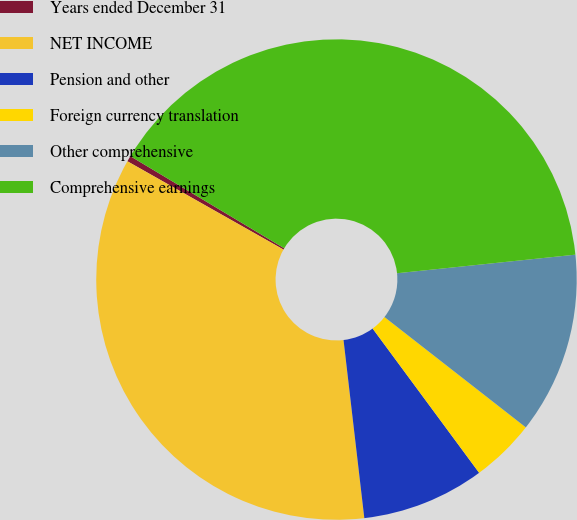Convert chart to OTSL. <chart><loc_0><loc_0><loc_500><loc_500><pie_chart><fcel>Years ended December 31<fcel>NET INCOME<fcel>Pension and other<fcel>Foreign currency translation<fcel>Other comprehensive<fcel>Comprehensive earnings<nl><fcel>0.39%<fcel>35.04%<fcel>8.27%<fcel>4.33%<fcel>12.2%<fcel>39.76%<nl></chart> 